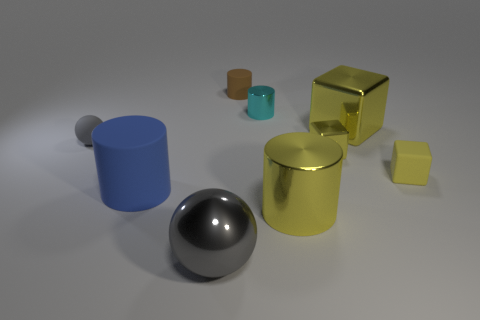How many yellow cubes must be subtracted to get 1 yellow cubes? 2 Add 1 metal cylinders. How many objects exist? 10 Subtract all cylinders. How many objects are left? 5 Add 9 large yellow cubes. How many large yellow cubes exist? 10 Subtract 0 red cylinders. How many objects are left? 9 Subtract all large rubber things. Subtract all large blue cylinders. How many objects are left? 7 Add 7 tiny gray objects. How many tiny gray objects are left? 8 